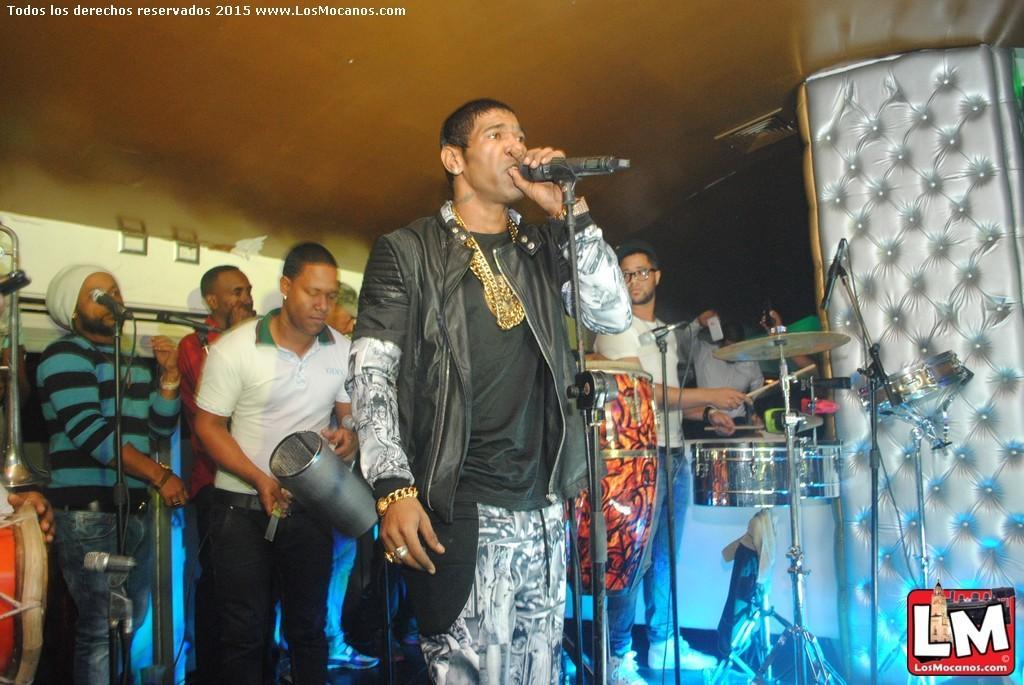In one or two sentences, can you explain what this image depicts? In this image I can see number of people are standing, I can also see one man is holding a mic and few are holding musical instruments. I can also see few mice and few more musical instruments. 